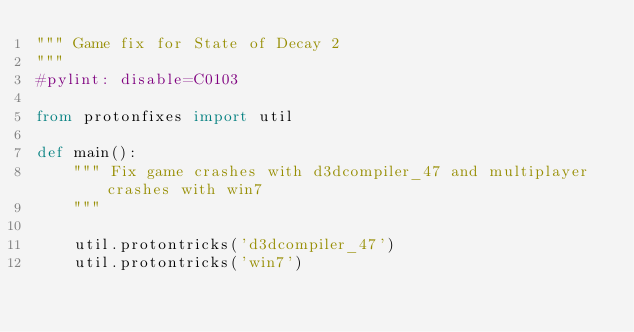<code> <loc_0><loc_0><loc_500><loc_500><_Python_>""" Game fix for State of Decay 2
"""
#pylint: disable=C0103

from protonfixes import util

def main():
    """ Fix game crashes with d3dcompiler_47 and multiplayer crashes with win7
    """

    util.protontricks('d3dcompiler_47')
    util.protontricks('win7')

</code> 